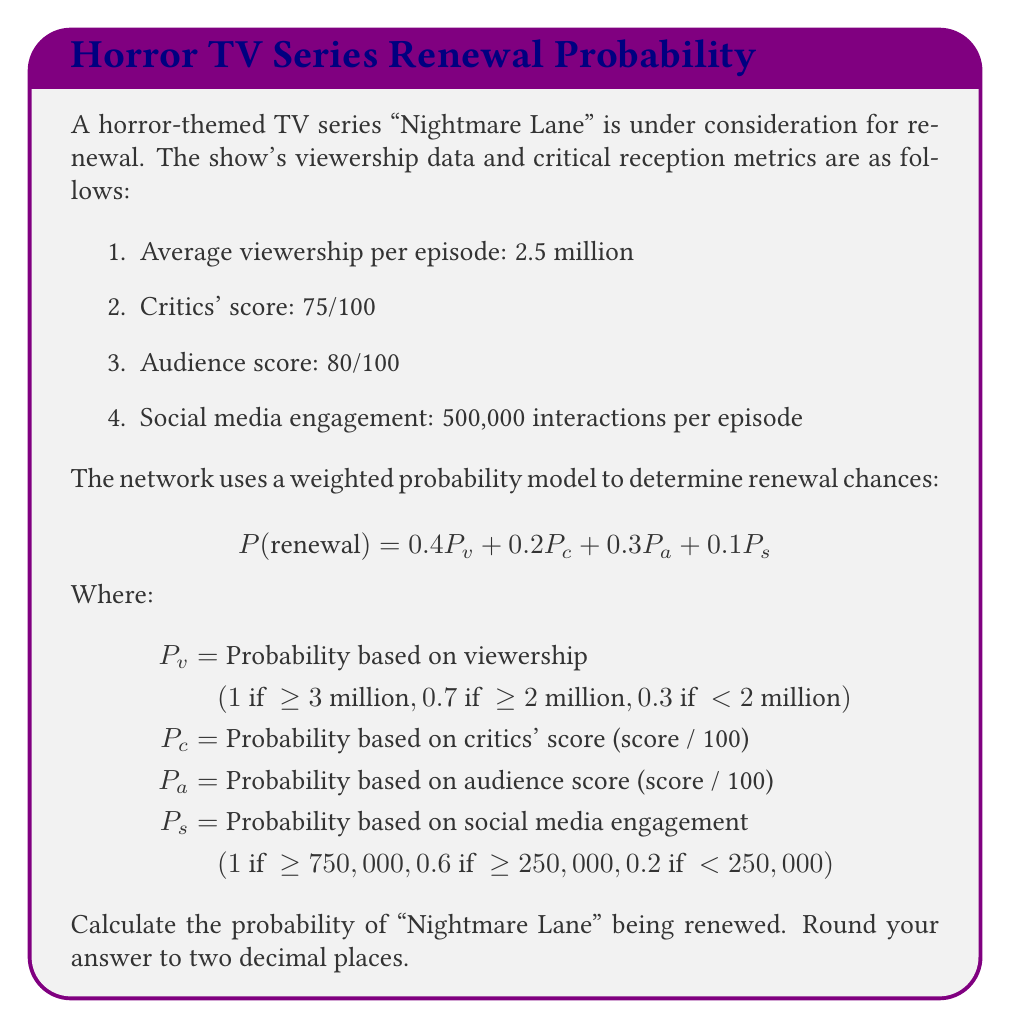Show me your answer to this math problem. Let's calculate each probability component:

1. $P_v$ (Viewership probability):
   The average viewership is 2.5 million, which is ≥ 2 million but < 3 million.
   Therefore, $P_v = 0.7$

2. $P_c$ (Critics' score probability):
   $P_c = 75/100 = 0.75$

3. $P_a$ (Audience score probability):
   $P_a = 80/100 = 0.8$

4. $P_s$ (Social media engagement probability):
   500,000 interactions is ≥ 250,000 but < 750,000.
   Therefore, $P_s = 0.6$

Now, let's plug these values into the weighted probability formula:

$$\begin{align*}
P(\text{renewal}) &= 0.4P_v + 0.2P_c + 0.3P_a + 0.1P_s \\
&= 0.4(0.7) + 0.2(0.75) + 0.3(0.8) + 0.1(0.6) \\
&= 0.28 + 0.15 + 0.24 + 0.06 \\
&= 0.73
\end{align*}$$

Rounding to two decimal places, we get 0.73 or 73%.
Answer: 0.73 